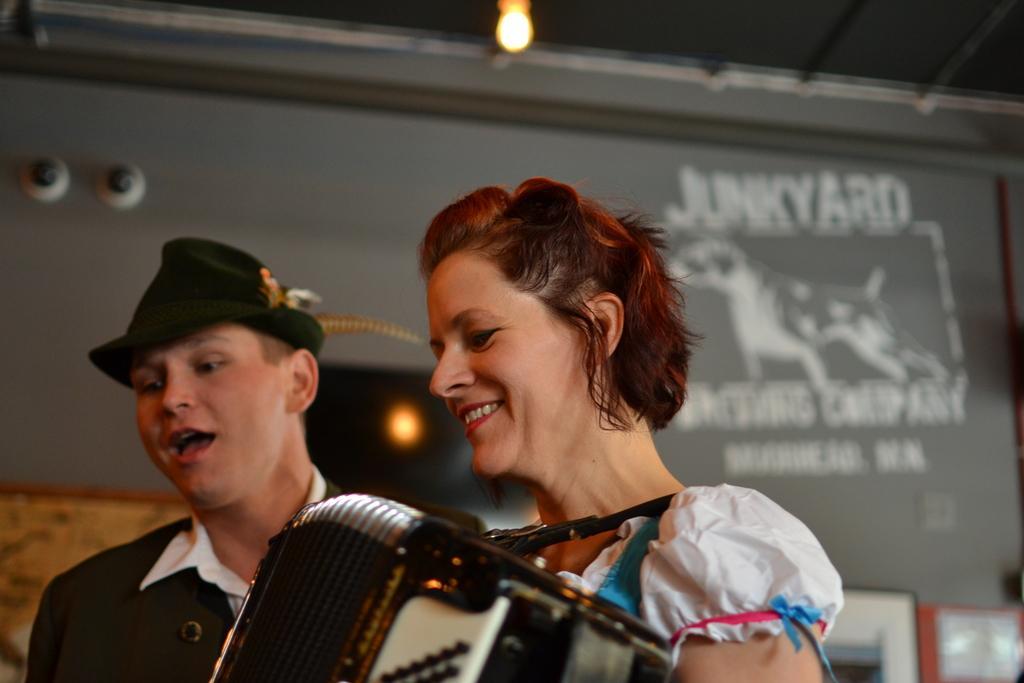How would you summarize this image in a sentence or two? In this image there are two persons, a person with accordions and concertinas, and in the background there are frames attached to the wall. 